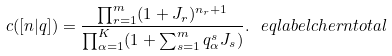<formula> <loc_0><loc_0><loc_500><loc_500>c ( [ n | q ] ) = \frac { \prod _ { r = 1 } ^ { m } ( 1 + J _ { r } ) ^ { n _ { r } + 1 } } { \prod _ { \alpha = 1 } ^ { K } ( 1 + \sum _ { s = 1 } ^ { m } q _ { \alpha } ^ { s } J _ { s } ) } . \ e q l a b e l { c h e r n t o t a l }</formula> 